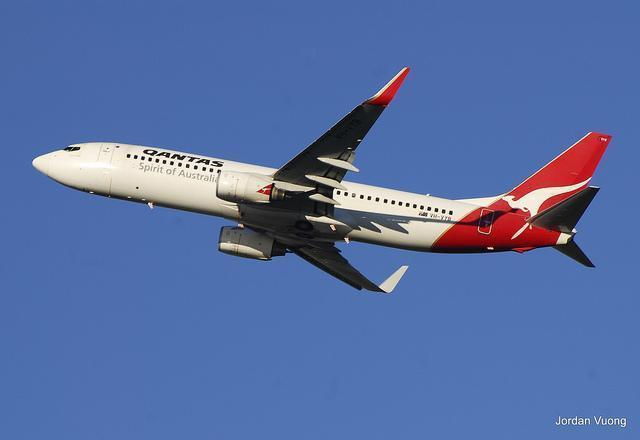How many people are driving a motorcycle in this image?
Give a very brief answer. 0. 